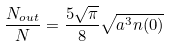Convert formula to latex. <formula><loc_0><loc_0><loc_500><loc_500>\frac { N _ { o u t } } { N } = \frac { 5 \sqrt { \pi } } { 8 } \sqrt { a ^ { 3 } n ( 0 ) }</formula> 